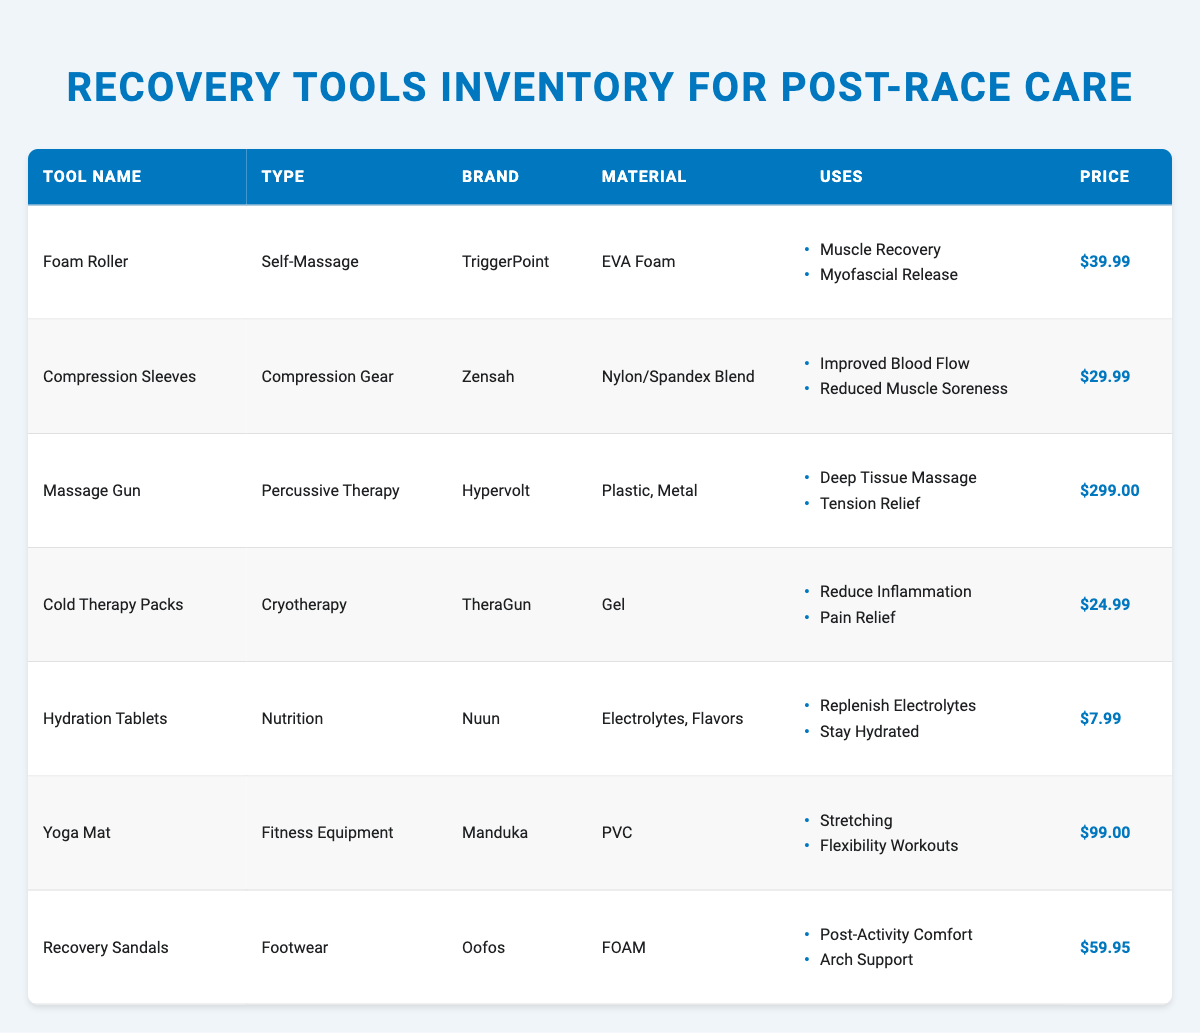What is the price of the Foam Roller? The Foam Roller is listed in the table, and its price is directly mentioned under the Price column. The price for the Foam Roller is $39.99.
Answer: $39.99 Which tool is categorized as Compression Gear? The table indicates the types of each tool, and by scanning through the Type column, we find that Compression Sleeves is the tool categorized under Compression Gear.
Answer: Compression Sleeves Are Yoga Mats made from PVC? In the table, the Material column for Yoga Mat specifies that it is made from PVC. Therefore, the statement is true.
Answer: Yes What are the uses of the Massage Gun? To find the uses of the Massage Gun, we check the table for the corresponding entry under the Uses column. It lists Deep Tissue Massage and Tension Relief as the uses.
Answer: Deep Tissue Massage, Tension Relief What is the total cost of the Cold Therapy Packs and Hydration Tablets? We first locate their prices in the table: Cold Therapy Packs is $24.99 and Hydration Tablets is $7.99. Next, we sum these two prices: $24.99 + $7.99 = $32.98, producing the total cost.
Answer: $32.98 Which recovery tool has the highest price, and what is that price? The table requires a review of the Price column to identify the tool with the highest cost. Scanning through the values reveals the Massage Gun as the most expensive at $299.00.
Answer: Massage Gun, $299.00 How many tools are listed for muscle recovery? We refer to the Uses column and count the entries mentioning muscle recovery. The Foam Roller, Compression Sleeves, and Massage Gun are all relevant, thus giving us a total of three tools that cater to muscle recovery.
Answer: 3 Do Recovery Sandals provide arch support? Looking at the Uses column for Recovery Sandals, there is a mention of Arch Support among its uses, confirming the statement is true.
Answer: Yes What is the average price of all recovery tools? First, we add all the prices together: $39.99 (Foam Roller) + $29.99 (Compression Sleeves) + $299.00 (Massage Gun) + $24.99 (Cold Therapy Packs) + $7.99 (Hydration Tablets) + $99.00 (Yoga Mat) + $59.95 (Recovery Sandals) = $560.91. Then, we divide this sum by the total number of tools, which is 7. Therefore, the average price is $560.91 / 7 = $80.13.
Answer: $80.13 